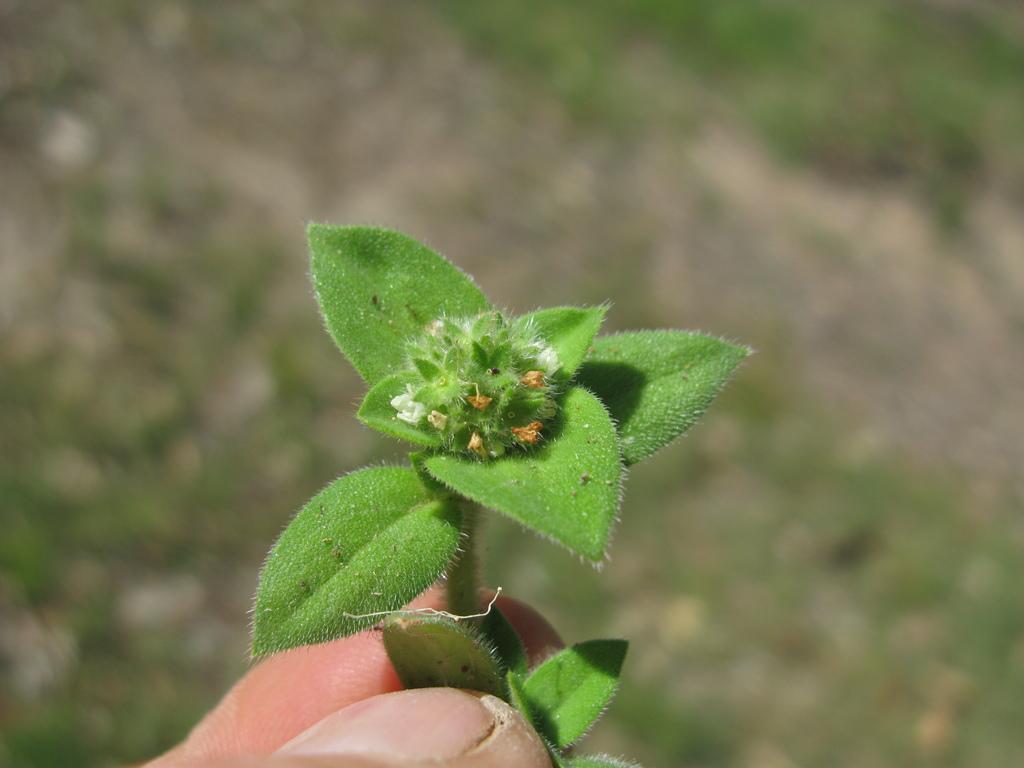Could you give a brief overview of what you see in this image? In the image we can see human hand, holding the plant and the background is blurred. 